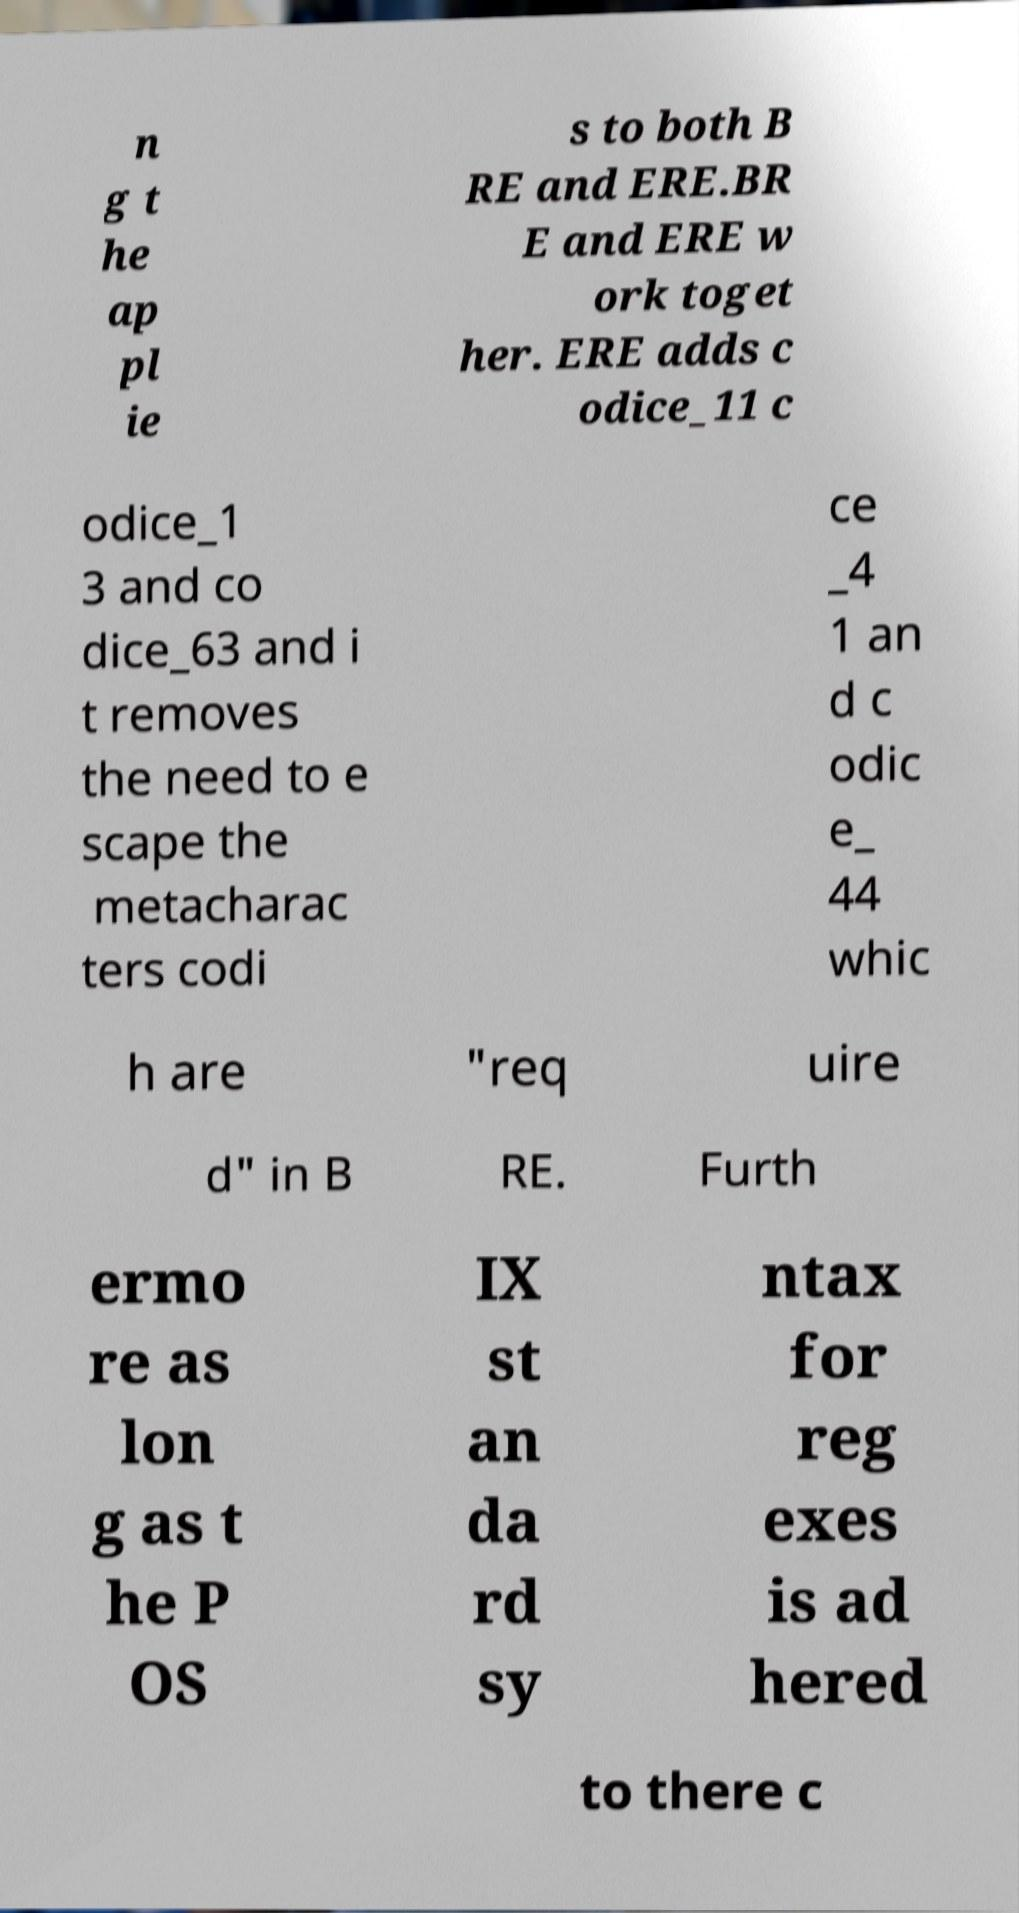Can you read and provide the text displayed in the image?This photo seems to have some interesting text. Can you extract and type it out for me? n g t he ap pl ie s to both B RE and ERE.BR E and ERE w ork toget her. ERE adds c odice_11 c odice_1 3 and co dice_63 and i t removes the need to e scape the metacharac ters codi ce _4 1 an d c odic e_ 44 whic h are "req uire d" in B RE. Furth ermo re as lon g as t he P OS IX st an da rd sy ntax for reg exes is ad hered to there c 